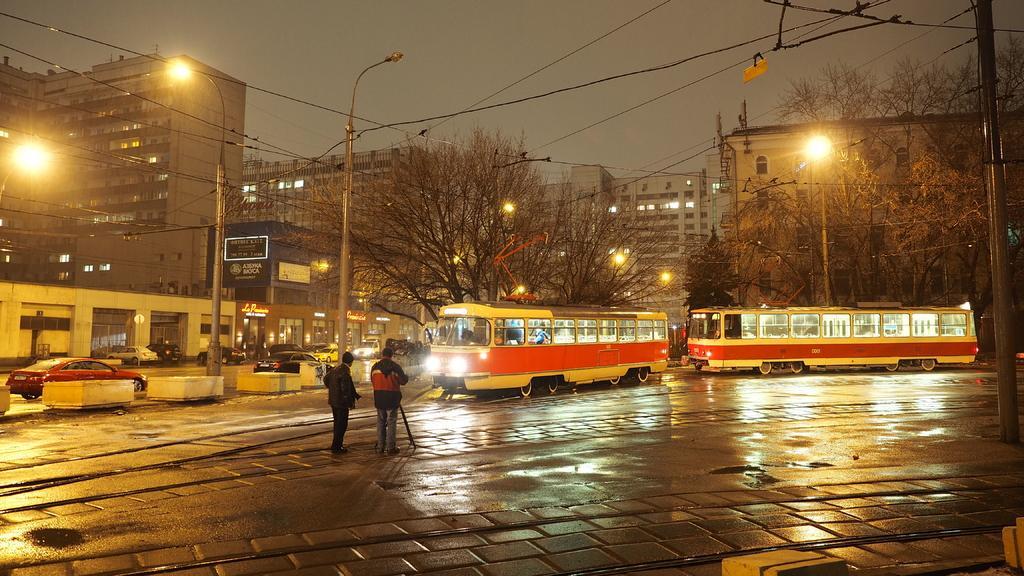How would you summarize this image in a sentence or two? These are the two teams on the tramway track. These are the windows and lights. I can see the street lights. This looks like a current pole with the current wires hanging. These are the trees. I can see the cars on the road. 